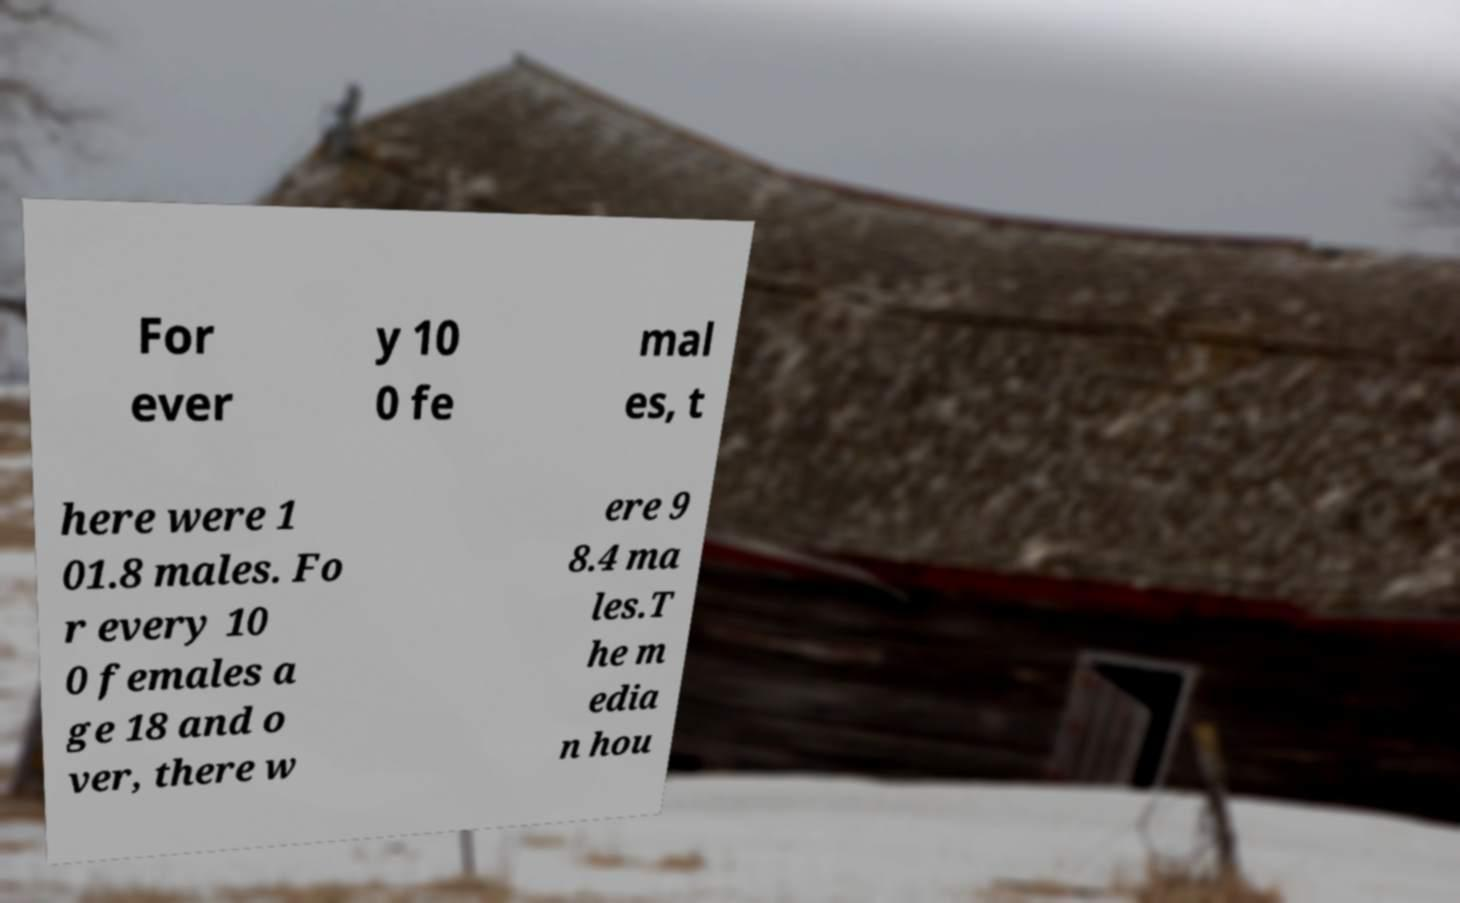Can you accurately transcribe the text from the provided image for me? For ever y 10 0 fe mal es, t here were 1 01.8 males. Fo r every 10 0 females a ge 18 and o ver, there w ere 9 8.4 ma les.T he m edia n hou 